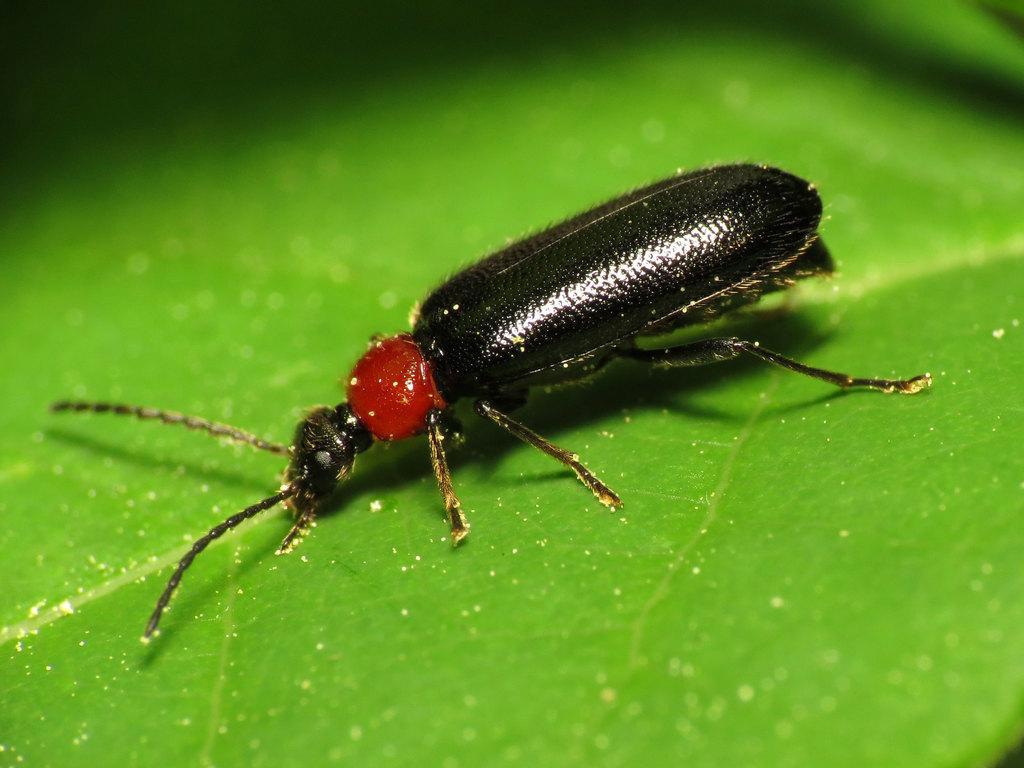Could you give a brief overview of what you see in this image? In this picture we can see an insect is present on a leaf. 